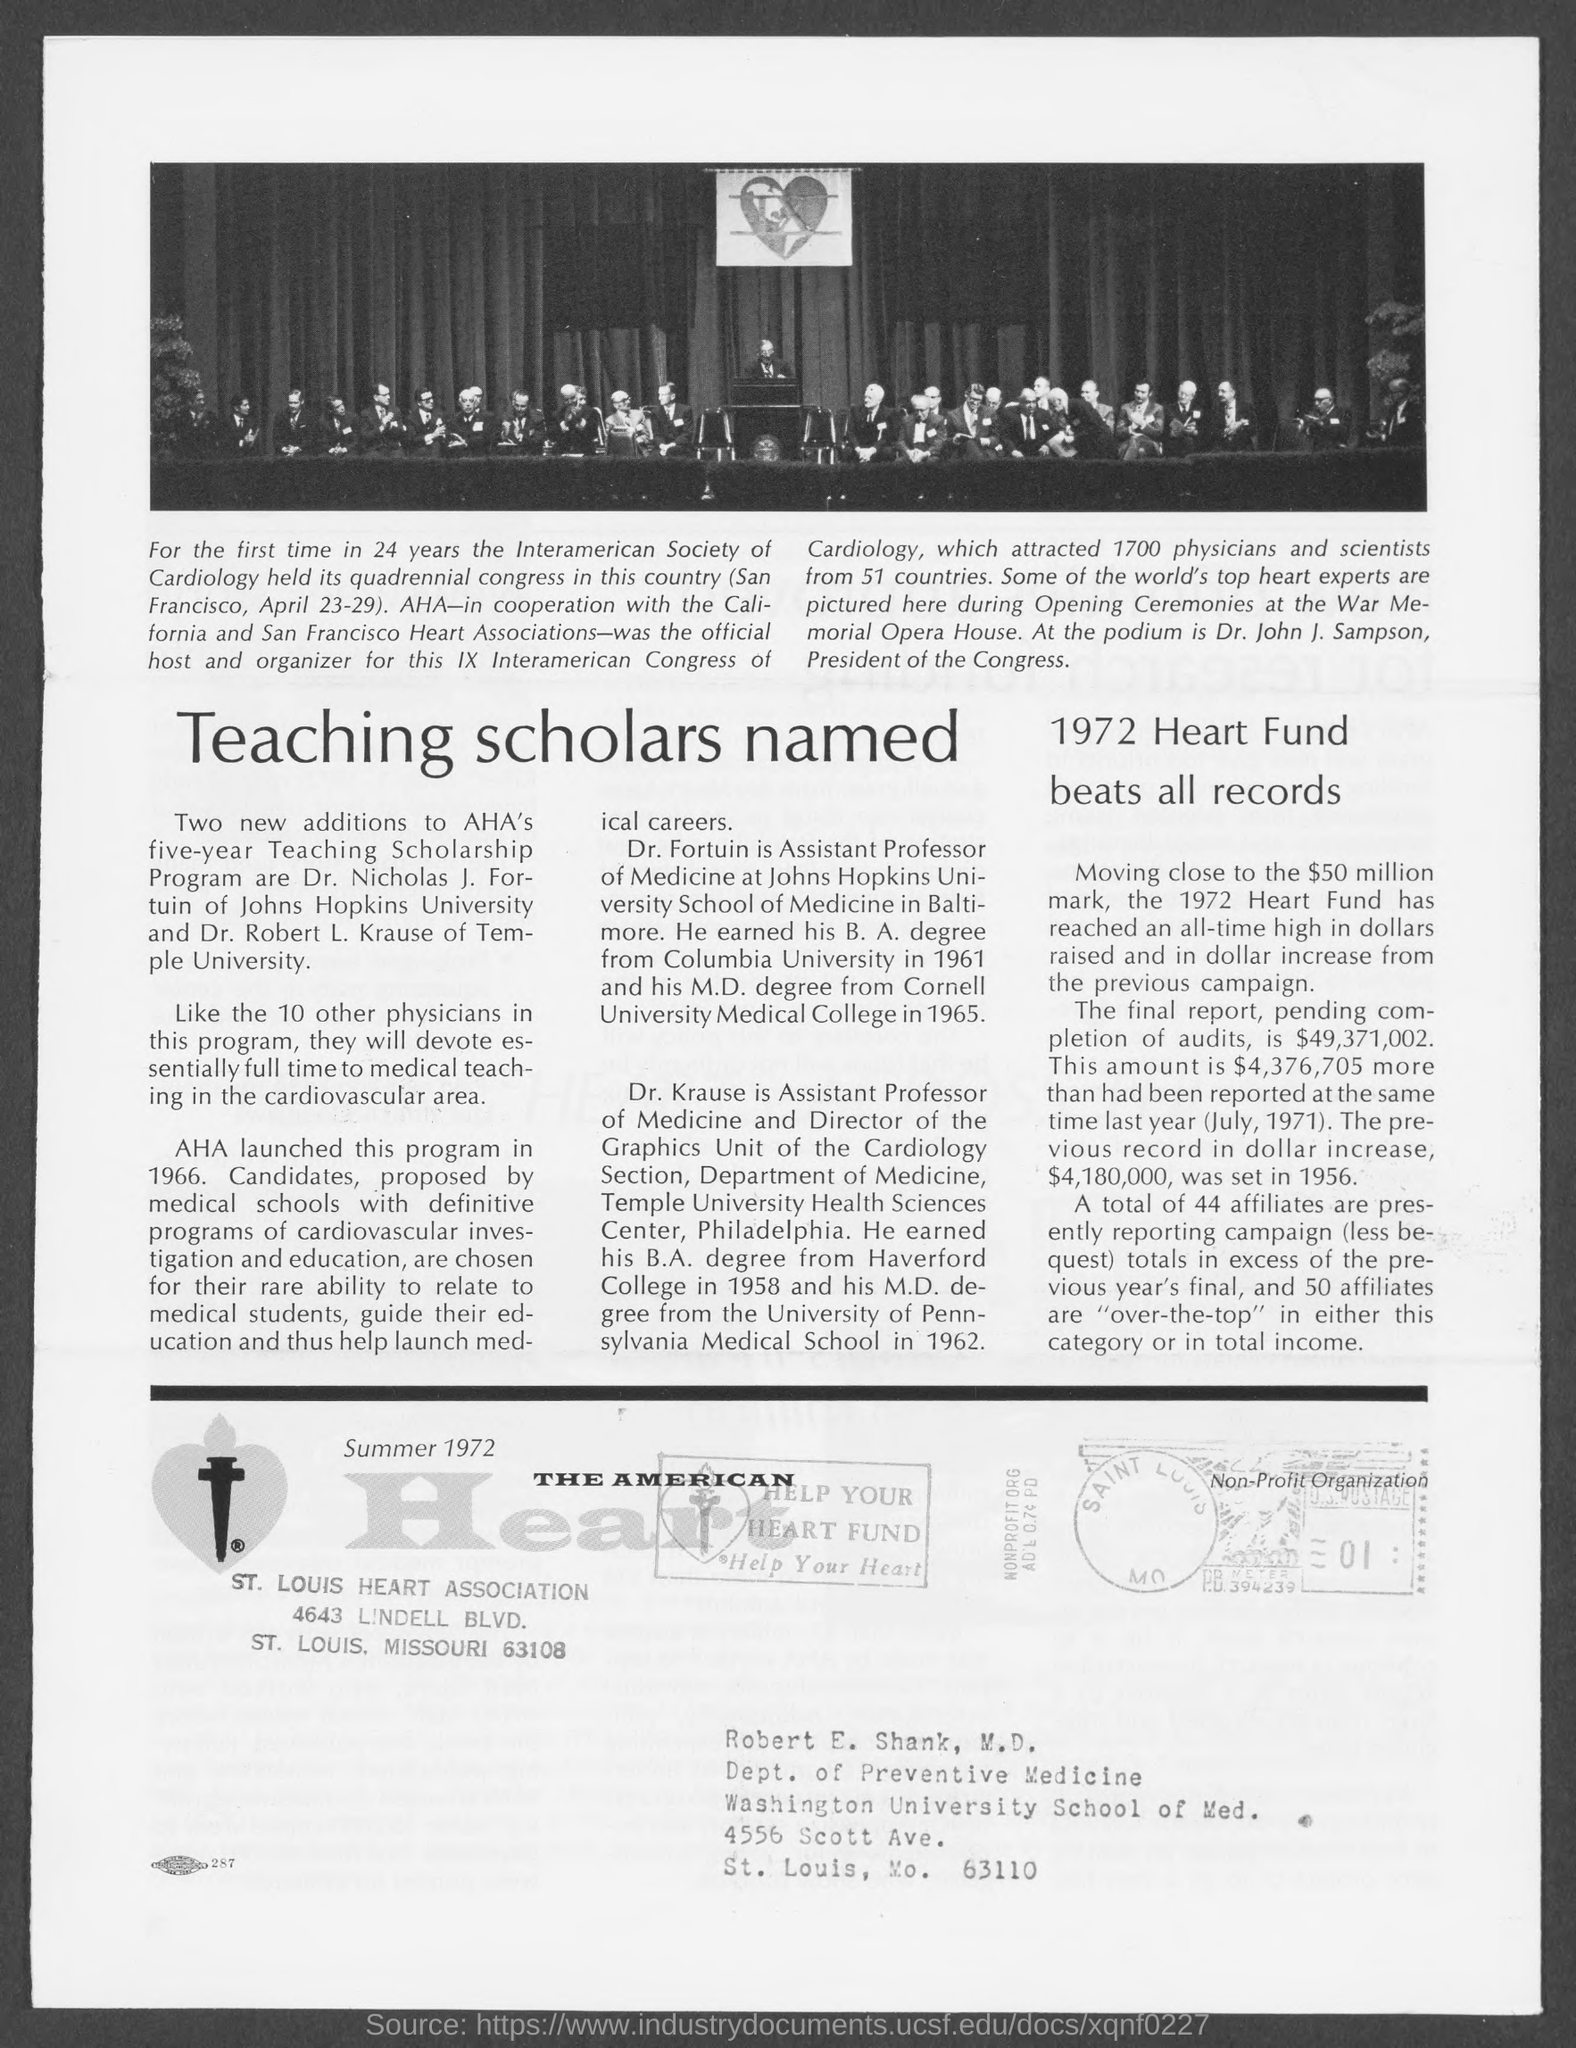What is the main heading of this feature?
Keep it short and to the point. Teaching scholars named. Who is the president of IX Interamerican Congress of Cardiology?
Your answer should be very brief. Dr. John J. Sampson. What is the number mentioned in a box in the bottom seal?
Make the answer very short. 01. 